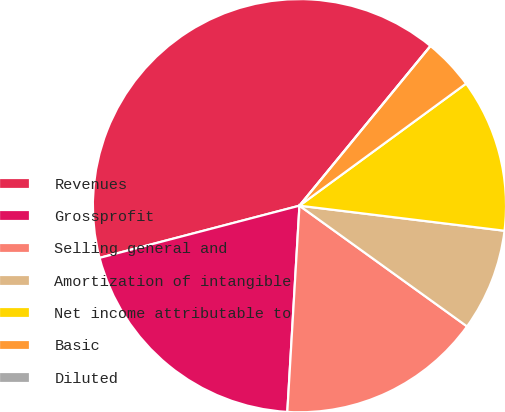<chart> <loc_0><loc_0><loc_500><loc_500><pie_chart><fcel>Revenues<fcel>Grossprofit<fcel>Selling general and<fcel>Amortization of intangible<fcel>Net income attributable to<fcel>Basic<fcel>Diluted<nl><fcel>40.0%<fcel>20.0%<fcel>16.0%<fcel>8.0%<fcel>12.0%<fcel>4.0%<fcel>0.0%<nl></chart> 